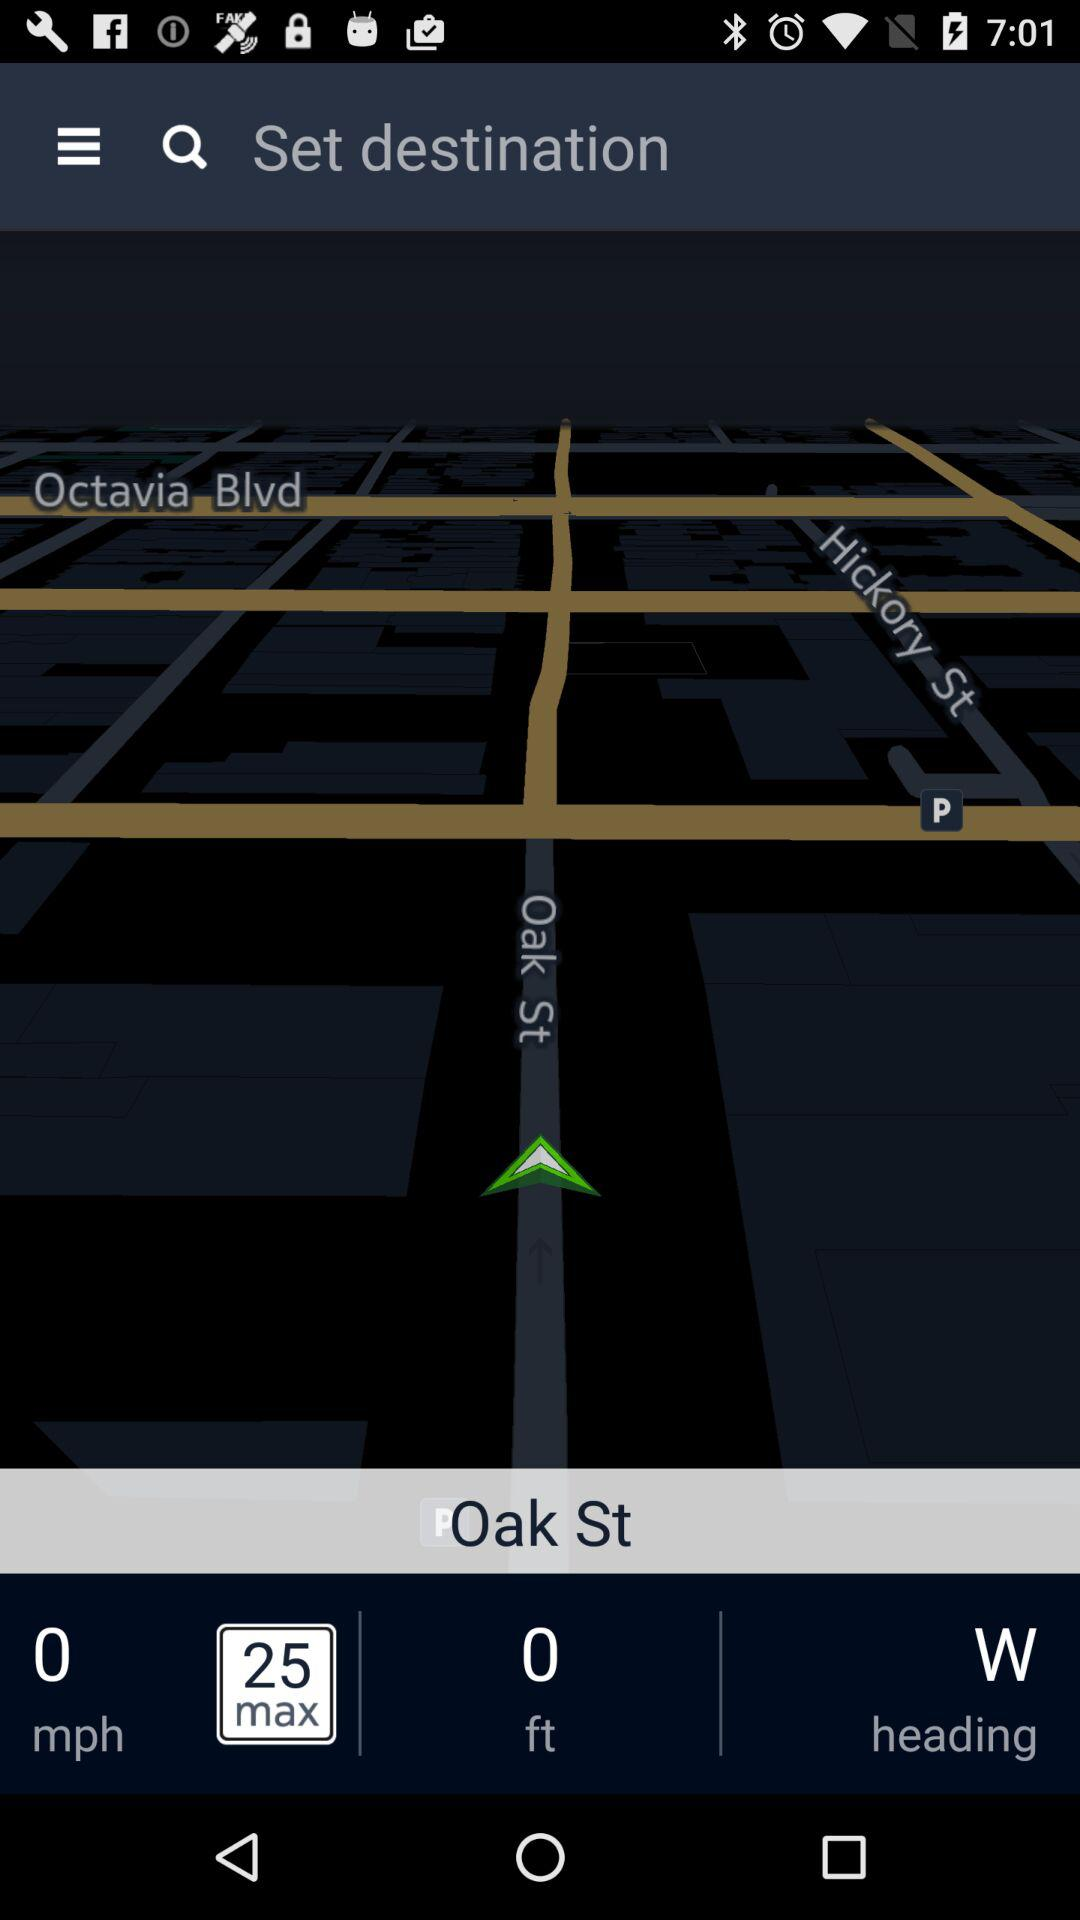What is the current speed limit?
Answer the question using a single word or phrase. 25 mph 